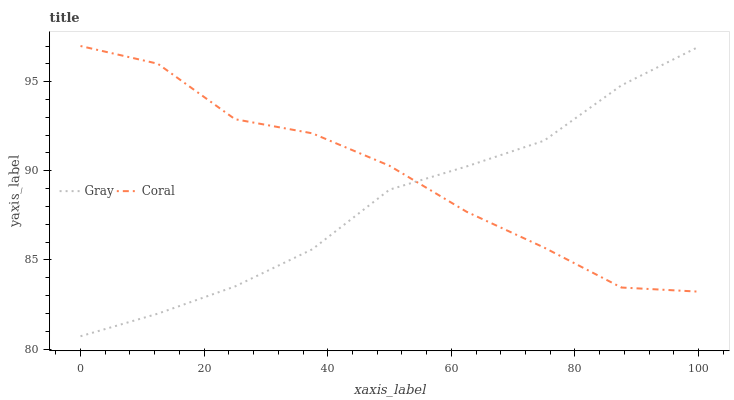Does Gray have the minimum area under the curve?
Answer yes or no. Yes. Does Coral have the maximum area under the curve?
Answer yes or no. Yes. Does Coral have the minimum area under the curve?
Answer yes or no. No. Is Gray the smoothest?
Answer yes or no. Yes. Is Coral the roughest?
Answer yes or no. Yes. Is Coral the smoothest?
Answer yes or no. No. Does Gray have the lowest value?
Answer yes or no. Yes. Does Coral have the lowest value?
Answer yes or no. No. Does Coral have the highest value?
Answer yes or no. Yes. Does Gray intersect Coral?
Answer yes or no. Yes. Is Gray less than Coral?
Answer yes or no. No. Is Gray greater than Coral?
Answer yes or no. No. 